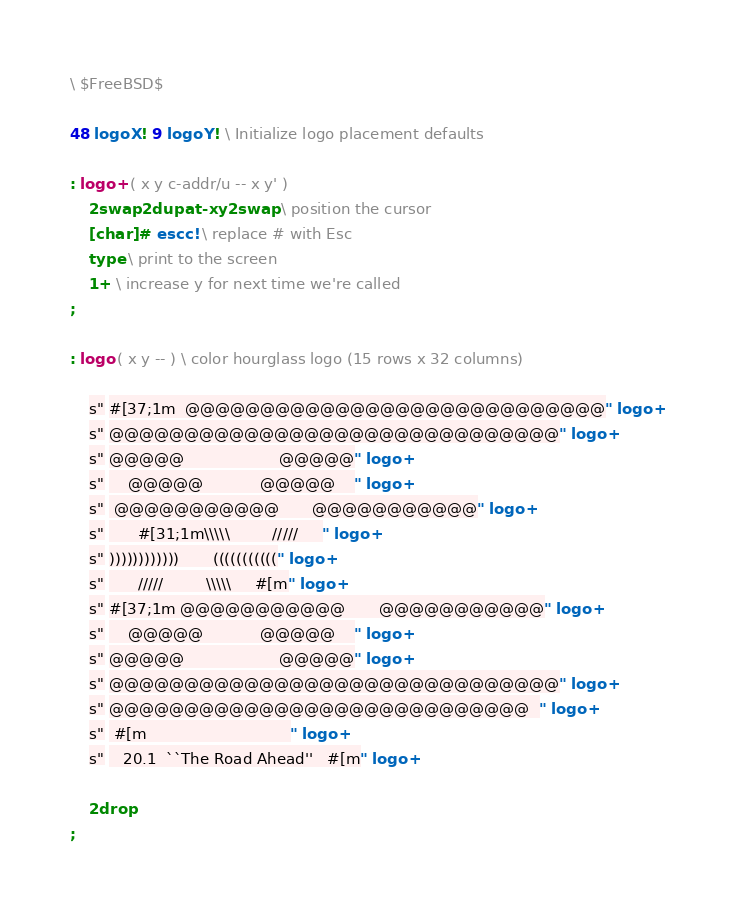Convert code to text. <code><loc_0><loc_0><loc_500><loc_500><_Forth_>\ $FreeBSD$

48 logoX ! 9 logoY ! \ Initialize logo placement defaults

: logo+ ( x y c-addr/u -- x y' )
	2swap 2dup at-xy 2swap \ position the cursor
	[char] # escc! \ replace # with Esc
	type \ print to the screen
	1+ \ increase y for next time we're called
;

: logo ( x y -- ) \ color hourglass logo (15 rows x 32 columns)

	s" #[37;1m  @@@@@@@@@@@@@@@@@@@@@@@@@@@@" logo+
	s" @@@@@@@@@@@@@@@@@@@@@@@@@@@@@@" logo+
	s" @@@@@                    @@@@@" logo+
	s"     @@@@@            @@@@@    " logo+
	s"  @@@@@@@@@@@       @@@@@@@@@@@" logo+
	s"       #[31;1m\\\\\         /////     " logo+
	s" ))))))))))))       (((((((((((" logo+
	s"       /////         \\\\\     #[m" logo+
	s" #[37;1m @@@@@@@@@@@       @@@@@@@@@@@" logo+
	s"     @@@@@            @@@@@    " logo+
	s" @@@@@                    @@@@@" logo+
	s" @@@@@@@@@@@@@@@@@@@@@@@@@@@@@@" logo+
	s" @@@@@@@@@@@@@@@@@@@@@@@@@@@@  " logo+
	s"  #[m                              " logo+
	s"    20.1  ``The Road Ahead''   #[m" logo+

	2drop
;
</code> 